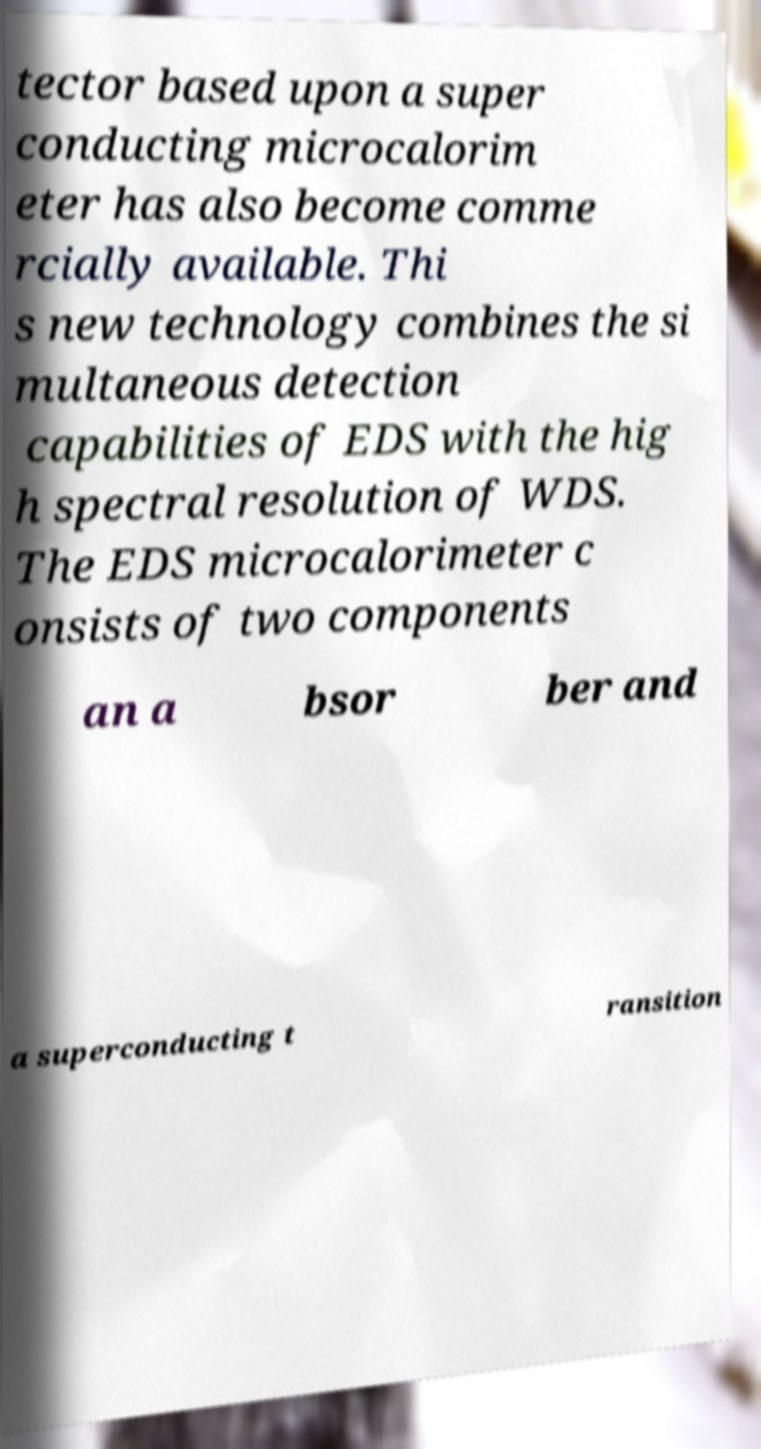Can you accurately transcribe the text from the provided image for me? tector based upon a super conducting microcalorim eter has also become comme rcially available. Thi s new technology combines the si multaneous detection capabilities of EDS with the hig h spectral resolution of WDS. The EDS microcalorimeter c onsists of two components an a bsor ber and a superconducting t ransition 